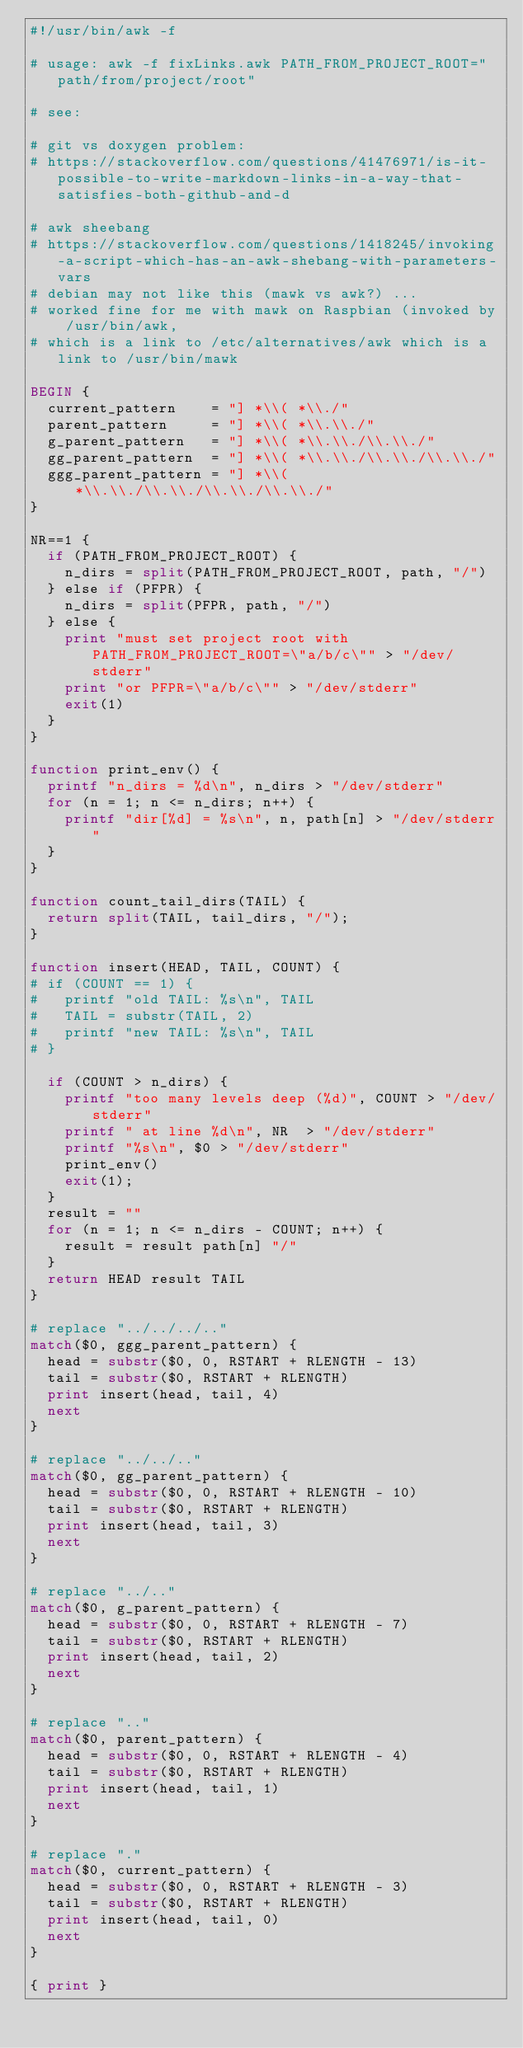Convert code to text. <code><loc_0><loc_0><loc_500><loc_500><_Awk_>#!/usr/bin/awk -f

# usage: awk -f fixLinks.awk PATH_FROM_PROJECT_ROOT="path/from/project/root"

# see:

# git vs doxygen problem:
# https://stackoverflow.com/questions/41476971/is-it-possible-to-write-markdown-links-in-a-way-that-satisfies-both-github-and-d

# awk sheebang
# https://stackoverflow.com/questions/1418245/invoking-a-script-which-has-an-awk-shebang-with-parameters-vars
# debian may not like this (mawk vs awk?) ...
# worked fine for me with mawk on Raspbian (invoked by /usr/bin/awk,
# which is a link to /etc/alternatives/awk which is a link to /usr/bin/mawk

BEGIN {
	current_pattern    = "] *\\( *\\./"
	parent_pattern     = "] *\\( *\\.\\./"
	g_parent_pattern   = "] *\\( *\\.\\./\\.\\./"
	gg_parent_pattern  = "] *\\( *\\.\\./\\.\\./\\.\\./"
	ggg_parent_pattern = "] *\\( *\\.\\./\\.\\./\\.\\./\\.\\./"
}

NR==1 {
	if (PATH_FROM_PROJECT_ROOT) {
		n_dirs = split(PATH_FROM_PROJECT_ROOT, path, "/")
	} else if (PFPR) {
		n_dirs = split(PFPR, path, "/")
	} else {
		print "must set project root with PATH_FROM_PROJECT_ROOT=\"a/b/c\"" > "/dev/stderr"
		print "or PFPR=\"a/b/c\"" > "/dev/stderr"
		exit(1)
	}
}

function print_env() {
	printf "n_dirs = %d\n", n_dirs > "/dev/stderr"
	for (n = 1; n <= n_dirs; n++) {
		printf "dir[%d] = %s\n", n, path[n] > "/dev/stderr"
	}
}

function count_tail_dirs(TAIL) {
	return split(TAIL, tail_dirs, "/");
}

function insert(HEAD, TAIL, COUNT) {
#	if (COUNT == 1) {
#		printf "old TAIL: %s\n", TAIL
#		TAIL = substr(TAIL, 2)
#		printf "new TAIL: %s\n", TAIL
#	}

	if (COUNT > n_dirs) {
		printf "too many levels deep (%d)", COUNT > "/dev/stderr"
		printf " at line %d\n", NR  > "/dev/stderr"
		printf "%s\n", $0 > "/dev/stderr"
		print_env()
		exit(1);
	}
	result = ""
	for (n = 1; n <= n_dirs - COUNT; n++) {
		result = result path[n] "/"
	}
	return HEAD result TAIL
}

# replace "../../../.."
match($0, ggg_parent_pattern) {
	head = substr($0, 0, RSTART + RLENGTH - 13)
	tail = substr($0, RSTART + RLENGTH)
	print insert(head, tail, 4)
	next
}

# replace "../../.."
match($0, gg_parent_pattern) {
	head = substr($0, 0, RSTART + RLENGTH - 10)
	tail = substr($0, RSTART + RLENGTH)
	print insert(head, tail, 3)
	next
}

# replace "../.."
match($0, g_parent_pattern) {
	head = substr($0, 0, RSTART + RLENGTH - 7)
	tail = substr($0, RSTART + RLENGTH)
	print insert(head, tail, 2)
	next
}

# replace ".."
match($0, parent_pattern) {
	head = substr($0, 0, RSTART + RLENGTH - 4)
	tail = substr($0, RSTART + RLENGTH)
	print insert(head, tail, 1)
	next
}

# replace "."
match($0, current_pattern) {
	head = substr($0, 0, RSTART + RLENGTH - 3)
	tail = substr($0, RSTART + RLENGTH)
	print insert(head, tail, 0)
	next
}

{ print }
</code> 